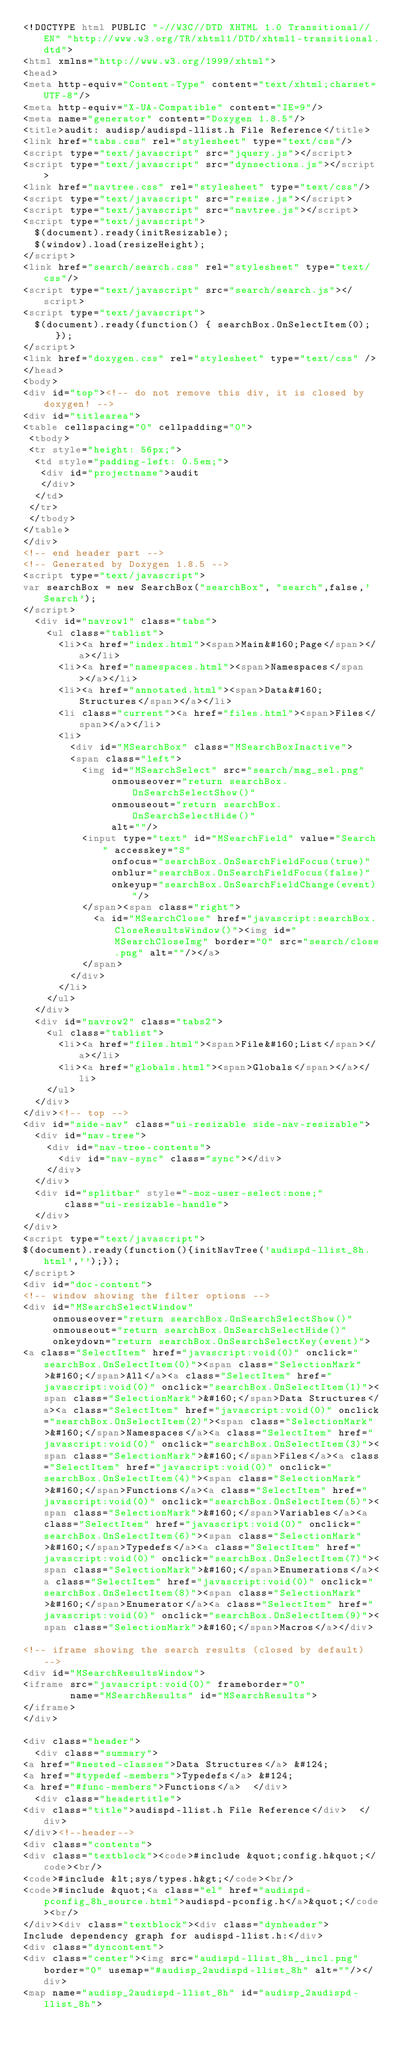<code> <loc_0><loc_0><loc_500><loc_500><_HTML_><!DOCTYPE html PUBLIC "-//W3C//DTD XHTML 1.0 Transitional//EN" "http://www.w3.org/TR/xhtml1/DTD/xhtml1-transitional.dtd">
<html xmlns="http://www.w3.org/1999/xhtml">
<head>
<meta http-equiv="Content-Type" content="text/xhtml;charset=UTF-8"/>
<meta http-equiv="X-UA-Compatible" content="IE=9"/>
<meta name="generator" content="Doxygen 1.8.5"/>
<title>audit: audisp/audispd-llist.h File Reference</title>
<link href="tabs.css" rel="stylesheet" type="text/css"/>
<script type="text/javascript" src="jquery.js"></script>
<script type="text/javascript" src="dynsections.js"></script>
<link href="navtree.css" rel="stylesheet" type="text/css"/>
<script type="text/javascript" src="resize.js"></script>
<script type="text/javascript" src="navtree.js"></script>
<script type="text/javascript">
  $(document).ready(initResizable);
  $(window).load(resizeHeight);
</script>
<link href="search/search.css" rel="stylesheet" type="text/css"/>
<script type="text/javascript" src="search/search.js"></script>
<script type="text/javascript">
  $(document).ready(function() { searchBox.OnSelectItem(0); });
</script>
<link href="doxygen.css" rel="stylesheet" type="text/css" />
</head>
<body>
<div id="top"><!-- do not remove this div, it is closed by doxygen! -->
<div id="titlearea">
<table cellspacing="0" cellpadding="0">
 <tbody>
 <tr style="height: 56px;">
  <td style="padding-left: 0.5em;">
   <div id="projectname">audit
   </div>
  </td>
 </tr>
 </tbody>
</table>
</div>
<!-- end header part -->
<!-- Generated by Doxygen 1.8.5 -->
<script type="text/javascript">
var searchBox = new SearchBox("searchBox", "search",false,'Search');
</script>
  <div id="navrow1" class="tabs">
    <ul class="tablist">
      <li><a href="index.html"><span>Main&#160;Page</span></a></li>
      <li><a href="namespaces.html"><span>Namespaces</span></a></li>
      <li><a href="annotated.html"><span>Data&#160;Structures</span></a></li>
      <li class="current"><a href="files.html"><span>Files</span></a></li>
      <li>
        <div id="MSearchBox" class="MSearchBoxInactive">
        <span class="left">
          <img id="MSearchSelect" src="search/mag_sel.png"
               onmouseover="return searchBox.OnSearchSelectShow()"
               onmouseout="return searchBox.OnSearchSelectHide()"
               alt=""/>
          <input type="text" id="MSearchField" value="Search" accesskey="S"
               onfocus="searchBox.OnSearchFieldFocus(true)" 
               onblur="searchBox.OnSearchFieldFocus(false)" 
               onkeyup="searchBox.OnSearchFieldChange(event)"/>
          </span><span class="right">
            <a id="MSearchClose" href="javascript:searchBox.CloseResultsWindow()"><img id="MSearchCloseImg" border="0" src="search/close.png" alt=""/></a>
          </span>
        </div>
      </li>
    </ul>
  </div>
  <div id="navrow2" class="tabs2">
    <ul class="tablist">
      <li><a href="files.html"><span>File&#160;List</span></a></li>
      <li><a href="globals.html"><span>Globals</span></a></li>
    </ul>
  </div>
</div><!-- top -->
<div id="side-nav" class="ui-resizable side-nav-resizable">
  <div id="nav-tree">
    <div id="nav-tree-contents">
      <div id="nav-sync" class="sync"></div>
    </div>
  </div>
  <div id="splitbar" style="-moz-user-select:none;" 
       class="ui-resizable-handle">
  </div>
</div>
<script type="text/javascript">
$(document).ready(function(){initNavTree('audispd-llist_8h.html','');});
</script>
<div id="doc-content">
<!-- window showing the filter options -->
<div id="MSearchSelectWindow"
     onmouseover="return searchBox.OnSearchSelectShow()"
     onmouseout="return searchBox.OnSearchSelectHide()"
     onkeydown="return searchBox.OnSearchSelectKey(event)">
<a class="SelectItem" href="javascript:void(0)" onclick="searchBox.OnSelectItem(0)"><span class="SelectionMark">&#160;</span>All</a><a class="SelectItem" href="javascript:void(0)" onclick="searchBox.OnSelectItem(1)"><span class="SelectionMark">&#160;</span>Data Structures</a><a class="SelectItem" href="javascript:void(0)" onclick="searchBox.OnSelectItem(2)"><span class="SelectionMark">&#160;</span>Namespaces</a><a class="SelectItem" href="javascript:void(0)" onclick="searchBox.OnSelectItem(3)"><span class="SelectionMark">&#160;</span>Files</a><a class="SelectItem" href="javascript:void(0)" onclick="searchBox.OnSelectItem(4)"><span class="SelectionMark">&#160;</span>Functions</a><a class="SelectItem" href="javascript:void(0)" onclick="searchBox.OnSelectItem(5)"><span class="SelectionMark">&#160;</span>Variables</a><a class="SelectItem" href="javascript:void(0)" onclick="searchBox.OnSelectItem(6)"><span class="SelectionMark">&#160;</span>Typedefs</a><a class="SelectItem" href="javascript:void(0)" onclick="searchBox.OnSelectItem(7)"><span class="SelectionMark">&#160;</span>Enumerations</a><a class="SelectItem" href="javascript:void(0)" onclick="searchBox.OnSelectItem(8)"><span class="SelectionMark">&#160;</span>Enumerator</a><a class="SelectItem" href="javascript:void(0)" onclick="searchBox.OnSelectItem(9)"><span class="SelectionMark">&#160;</span>Macros</a></div>

<!-- iframe showing the search results (closed by default) -->
<div id="MSearchResultsWindow">
<iframe src="javascript:void(0)" frameborder="0" 
        name="MSearchResults" id="MSearchResults">
</iframe>
</div>

<div class="header">
  <div class="summary">
<a href="#nested-classes">Data Structures</a> &#124;
<a href="#typedef-members">Typedefs</a> &#124;
<a href="#func-members">Functions</a>  </div>
  <div class="headertitle">
<div class="title">audispd-llist.h File Reference</div>  </div>
</div><!--header-->
<div class="contents">
<div class="textblock"><code>#include &quot;config.h&quot;</code><br/>
<code>#include &lt;sys/types.h&gt;</code><br/>
<code>#include &quot;<a class="el" href="audispd-pconfig_8h_source.html">audispd-pconfig.h</a>&quot;</code><br/>
</div><div class="textblock"><div class="dynheader">
Include dependency graph for audispd-llist.h:</div>
<div class="dyncontent">
<div class="center"><img src="audispd-llist_8h__incl.png" border="0" usemap="#audisp_2audispd-llist_8h" alt=""/></div>
<map name="audisp_2audispd-llist_8h" id="audisp_2audispd-llist_8h"></code> 